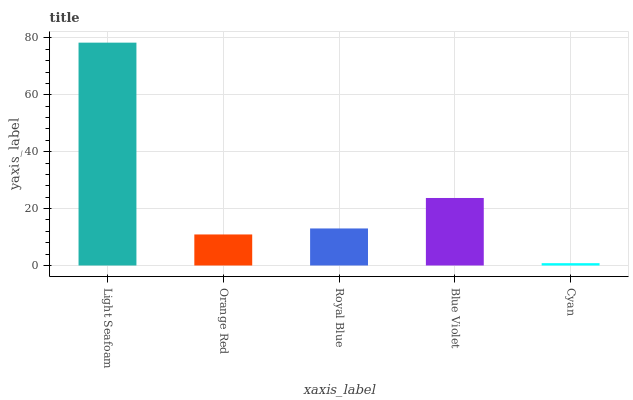Is Orange Red the minimum?
Answer yes or no. No. Is Orange Red the maximum?
Answer yes or no. No. Is Light Seafoam greater than Orange Red?
Answer yes or no. Yes. Is Orange Red less than Light Seafoam?
Answer yes or no. Yes. Is Orange Red greater than Light Seafoam?
Answer yes or no. No. Is Light Seafoam less than Orange Red?
Answer yes or no. No. Is Royal Blue the high median?
Answer yes or no. Yes. Is Royal Blue the low median?
Answer yes or no. Yes. Is Blue Violet the high median?
Answer yes or no. No. Is Cyan the low median?
Answer yes or no. No. 